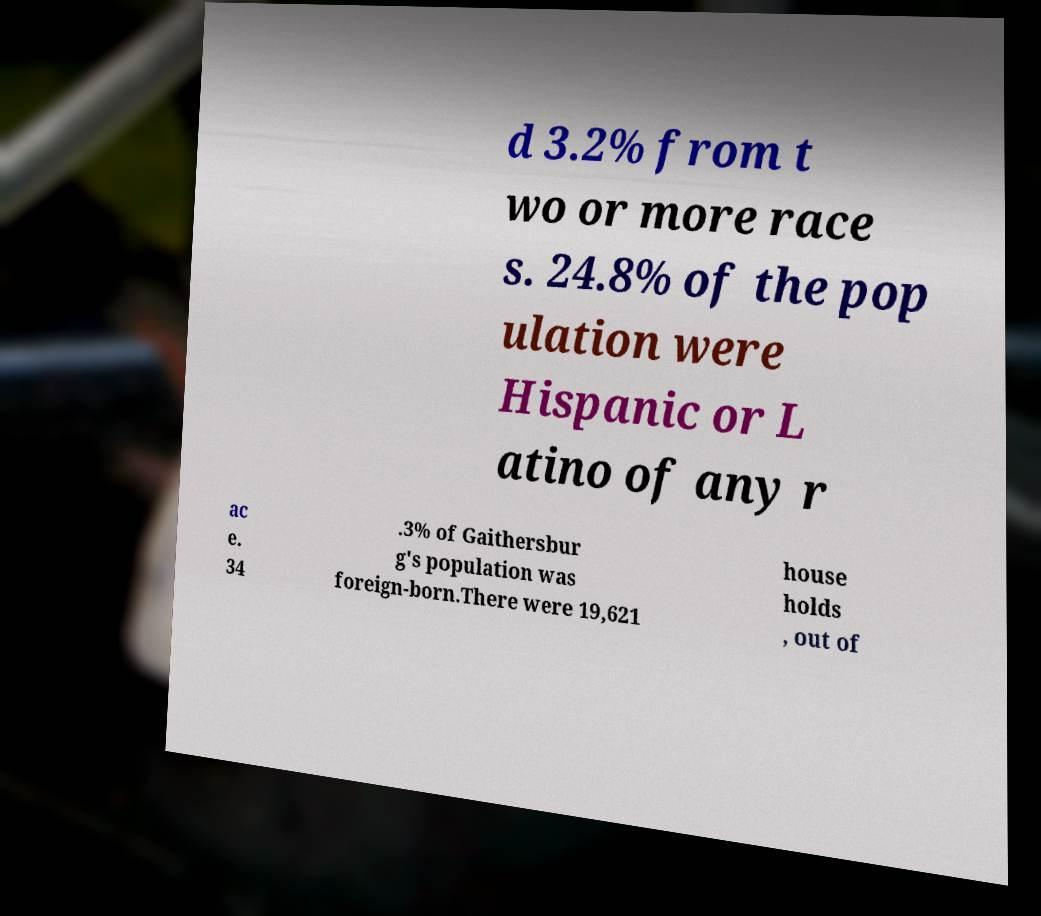For documentation purposes, I need the text within this image transcribed. Could you provide that? d 3.2% from t wo or more race s. 24.8% of the pop ulation were Hispanic or L atino of any r ac e. 34 .3% of Gaithersbur g's population was foreign-born.There were 19,621 house holds , out of 